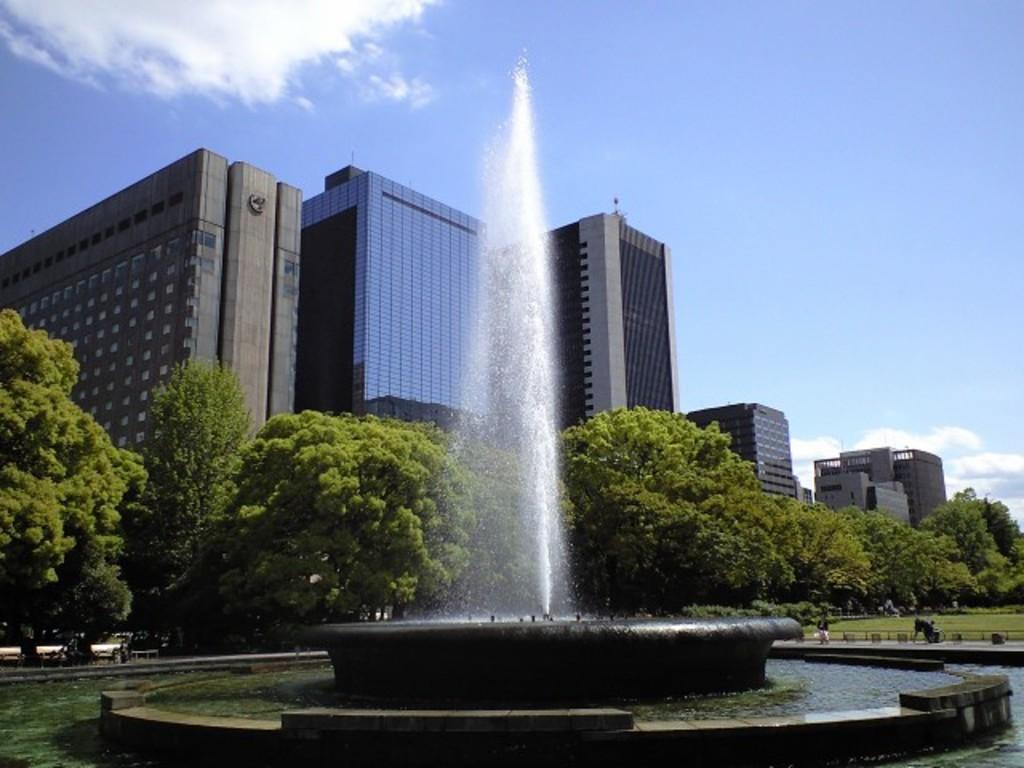How would you summarize this image in a sentence or two? In this picture we can see the water, fountain, grass, trees, buildings, some objects and in the background we can see the sky. 